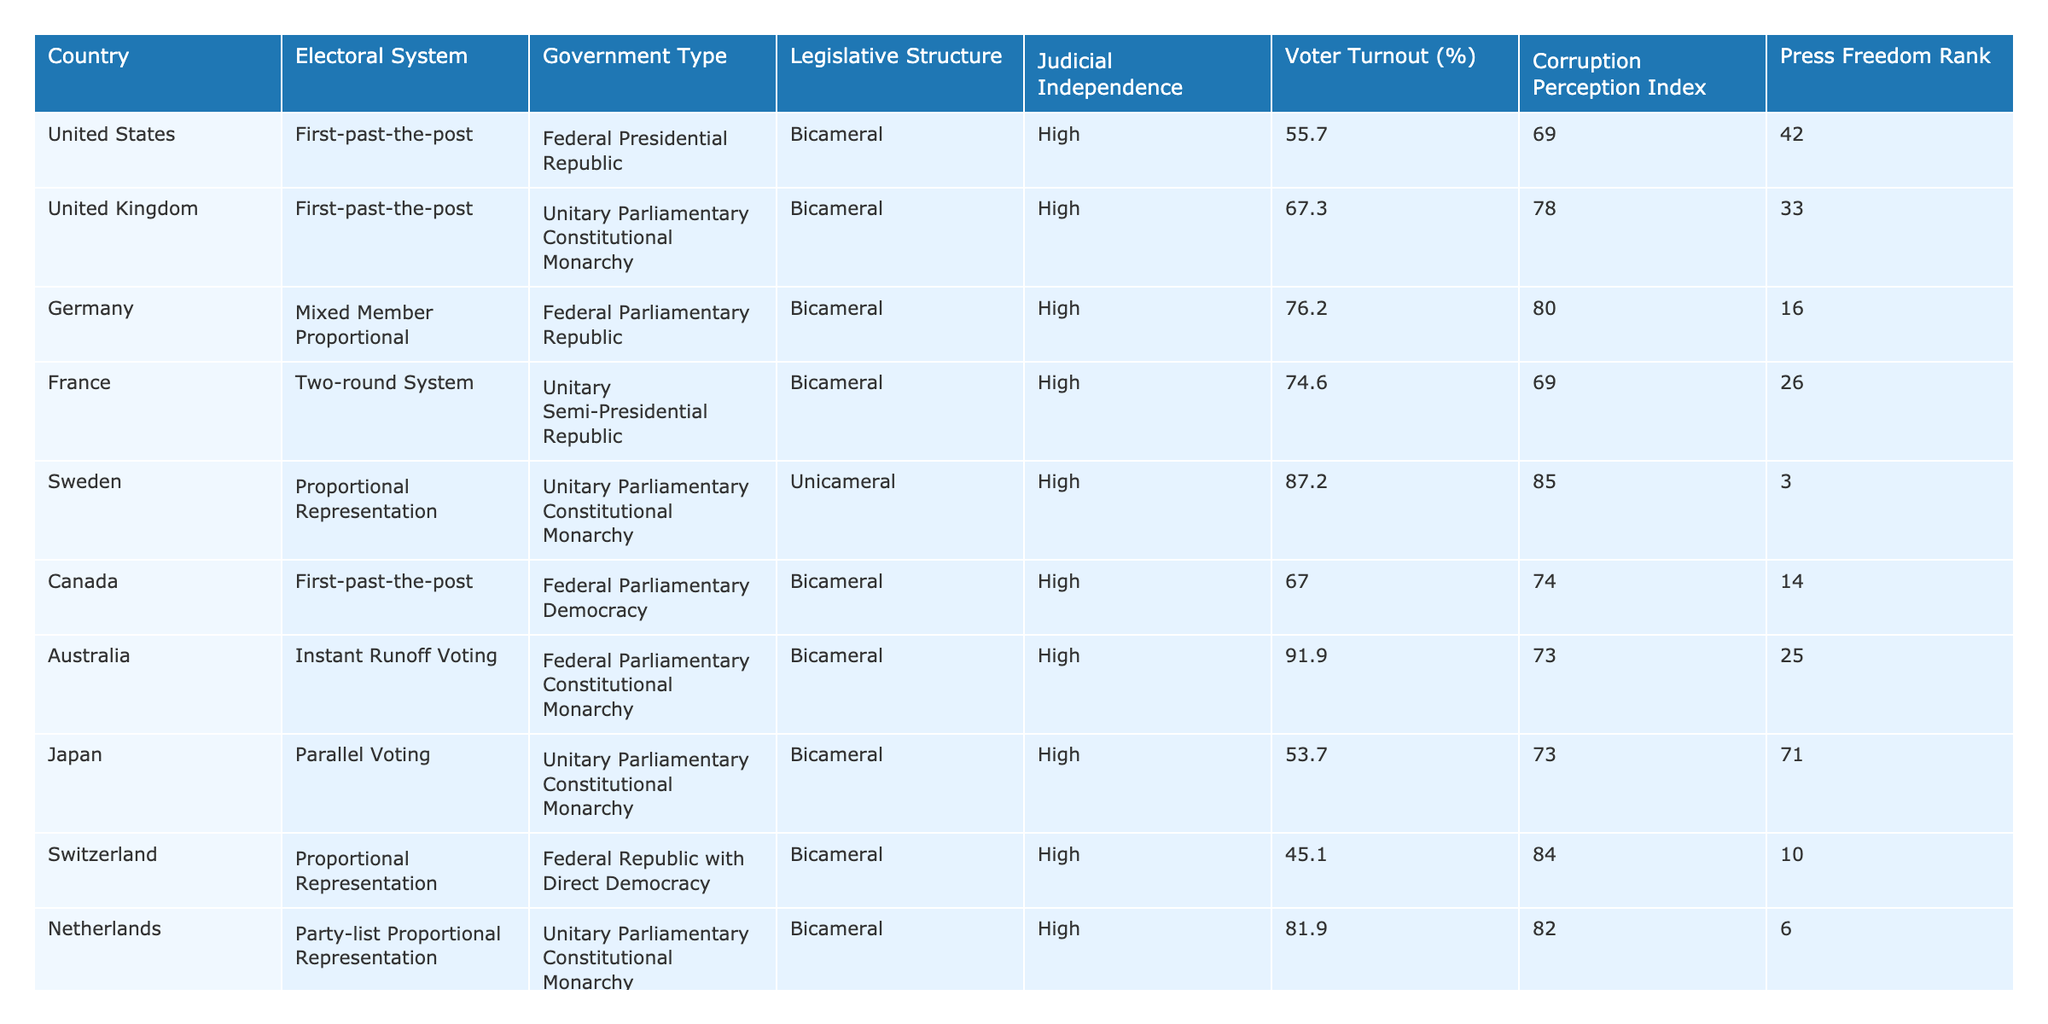What is the voter turnout percentage for Germany? The table lists the voter turnout percentages for each country. Looking at Germany, the voter turnout is noted in the respective column.
Answer: 76.2 Which country has the highest Corruption Perception Index? The Corruption Perception Index for each country is provided in the table. By examining the values, it's clear that Germany has the highest score listed at 80.
Answer: Germany What is the average voter turnout of the countries listed in the table? To find the average voter turnout, sum all the voter turnout percentages: (55.7 + 67.3 + 76.2 + 74.6 + 87.2 + 67.0 + 91.9 + 53.7 + 45.1 + 81.9) = 79.2. There are 10 countries, so the average is 792 / 10 = 79.2.
Answer: 79.2 Does the United States have a higher Press Freedom Rank than Canada? The Press Freedom Rank for the United States is 42, while for Canada it is 14. Since 42 is greater than 14, the statement is false.
Answer: No Which country has both a unicameral legislative structure and a high Corruption Perception Index? The table indicates that Sweden has a unicameral legislative structure and a Corruption Perception Index of 85, which is categorized as high.
Answer: Sweden How many countries have a Federal Government Type and a high voter turnout of over 80%? By examining the countries with a Federal government type, we note that Australia (91.9) and Germany (76.2) have high voter turnouts. However, only Australia surpasses 80%. Therefore, there is 1 country with these criteria.
Answer: 1 Is the electoral system of the United Kingdom the same as that of Canada? Both countries use the First-past-the-post electoral system as noted in the table. Since both match, the answer is yes.
Answer: Yes What is the difference in voter turnout between Sweden and Japan? Sweden has a voter turnout of 87.2% and Japan has 53.7%. To find the difference, calculate 87.2 - 53.7 = 33.5.
Answer: 33.5 Which country has the lowest Press Freedom Rank? The table indicates the Press Freedom Ranks for each country. Upon reviewing the list, Japan has the lowest rank at 71.
Answer: Japan 